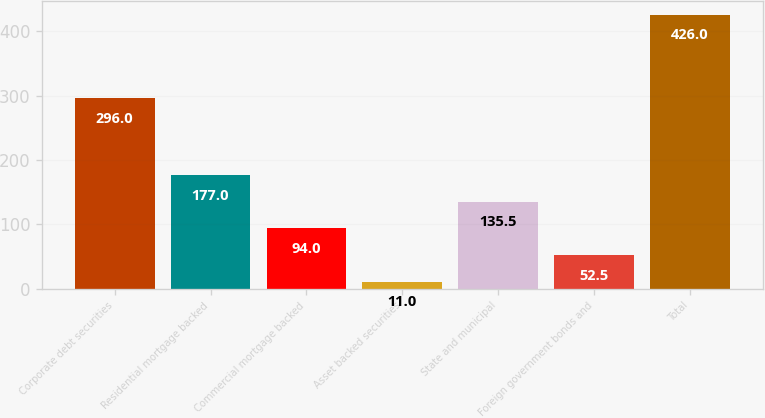Convert chart to OTSL. <chart><loc_0><loc_0><loc_500><loc_500><bar_chart><fcel>Corporate debt securities<fcel>Residential mortgage backed<fcel>Commercial mortgage backed<fcel>Asset backed securities<fcel>State and municipal<fcel>Foreign government bonds and<fcel>Total<nl><fcel>296<fcel>177<fcel>94<fcel>11<fcel>135.5<fcel>52.5<fcel>426<nl></chart> 